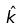<formula> <loc_0><loc_0><loc_500><loc_500>\hat { k }</formula> 